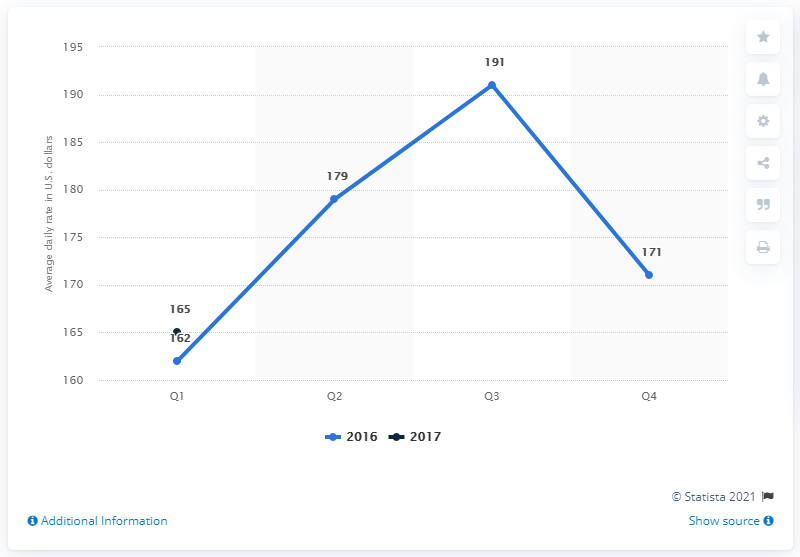Draw attention to some important aspects in this diagram. The average daily rate of hotels in Portland in the United States during the first quarter of 2017 was approximately 165 USD. 